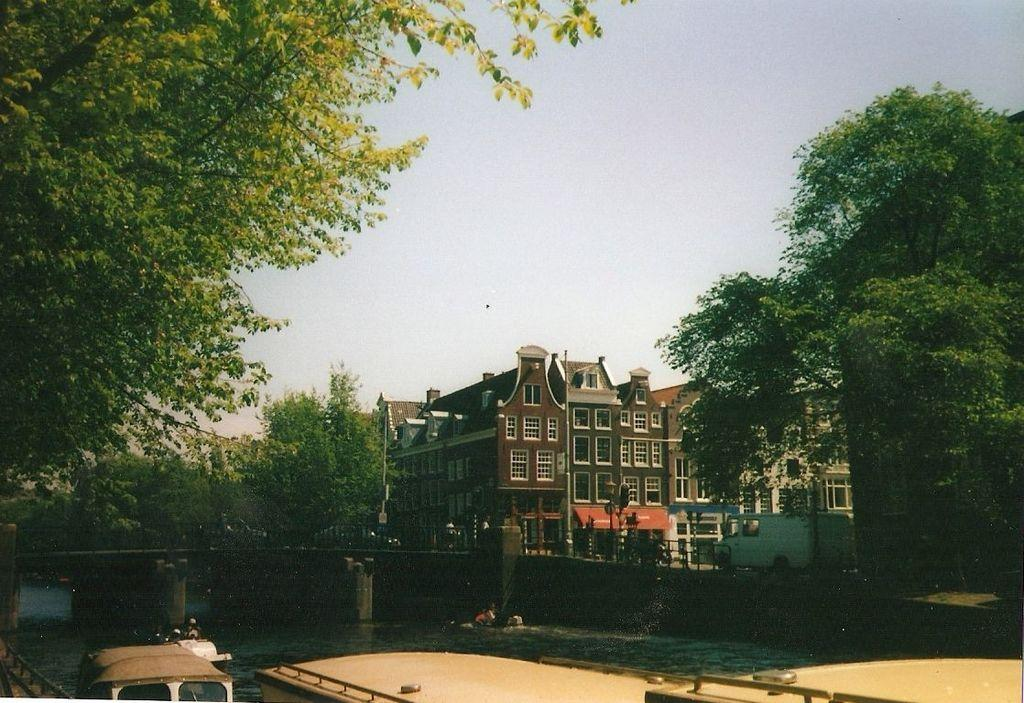What is located above the water in the image? There are boats above the water in the image. What type of structure can be seen in the image? There is a bridge in the image. What type of barrier is present in the image? A: There is a fence in the image. What type of vegetation is visible in the image? There are trees in the image. What type of vertical structures are present in the image? There are poles in the image. What type of man-made structures are visible in the image? There are buildings in the image. What can be seen in the background of the image? The sky is visible in the background of the image. How many divisions can be seen in the image? There is no mention of divisions in the image, so it cannot be determined how many there are. Is there a bike visible in the image? No, there is no bike present in the image. 